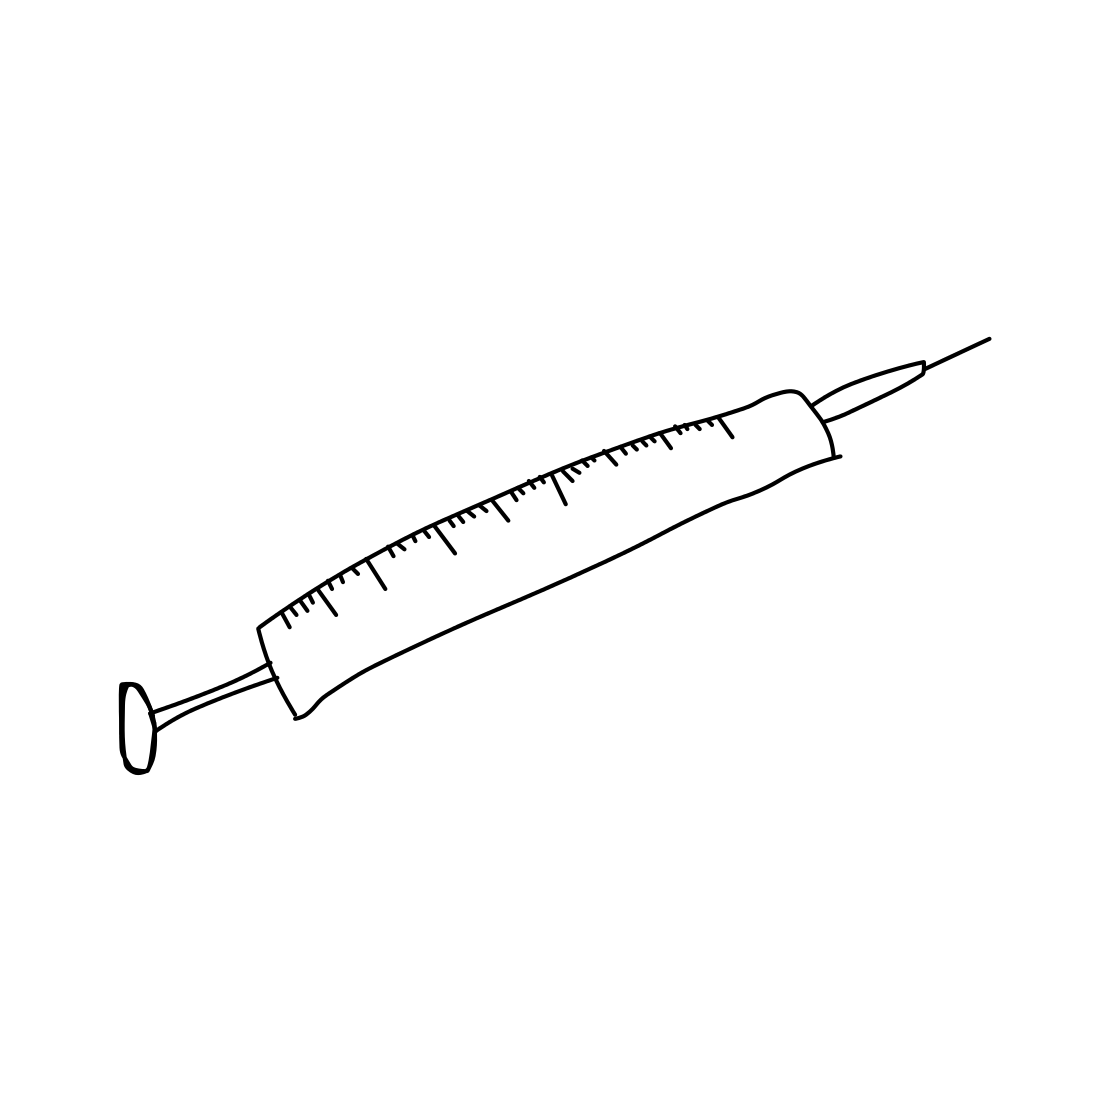In this task, you will identify whether the picture contains a living organism. The images given are black and white sketches drawn by human beings. If the picture depicts a living organism or part of a living organism, the output should be "Living". Otherwise, print "Non-Living" The sketch portrays a syringe, a tool designed for medical procedures like administering vaccines or medications, and for drawing blood or other fluids from the body. This instrument is crucial for numerous medical treatments and diagnostics. Despite its association with living organisms, the syringe itself is a man-made, inanimate object. Therefore, under the specified guidelines, we categorize the syringe as "Non-Living". 